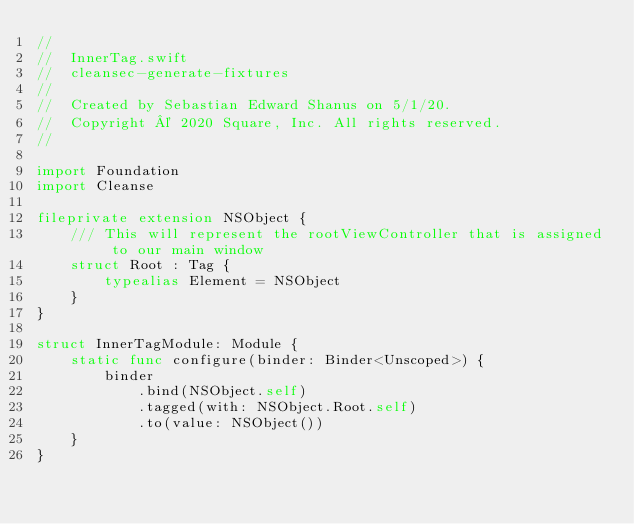Convert code to text. <code><loc_0><loc_0><loc_500><loc_500><_Swift_>//
//  InnerTag.swift
//  cleansec-generate-fixtures
//
//  Created by Sebastian Edward Shanus on 5/1/20.
//  Copyright © 2020 Square, Inc. All rights reserved.
//

import Foundation
import Cleanse

fileprivate extension NSObject {
    /// This will represent the rootViewController that is assigned to our main window
    struct Root : Tag {
        typealias Element = NSObject
    }
}

struct InnerTagModule: Module {
    static func configure(binder: Binder<Unscoped>) {
        binder
            .bind(NSObject.self)
            .tagged(with: NSObject.Root.self)
            .to(value: NSObject())
    }
}
</code> 